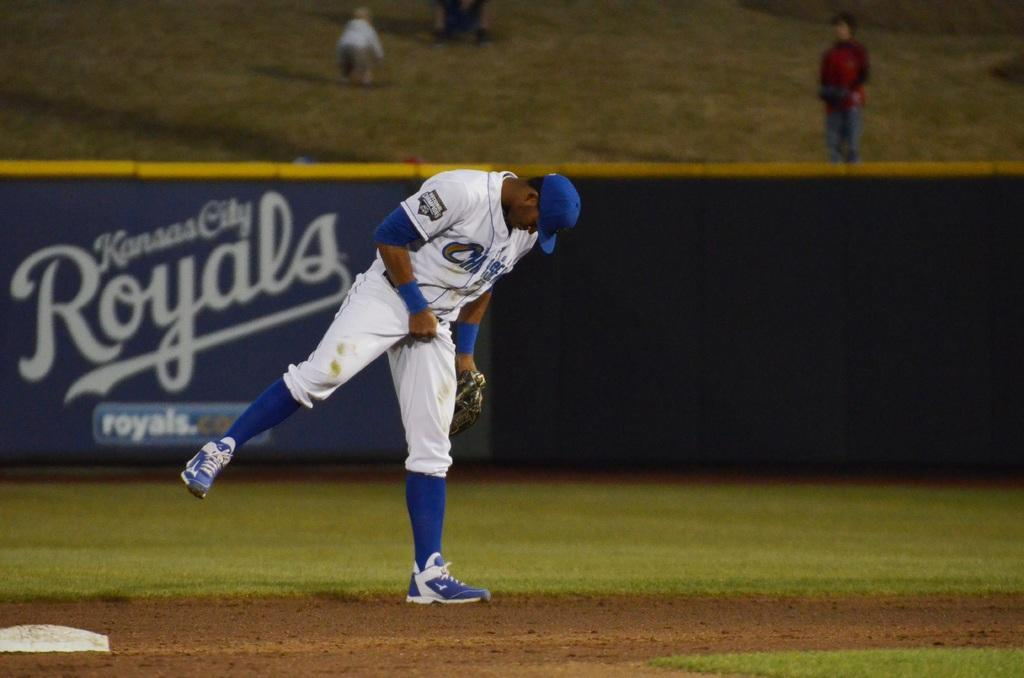<image>
Write a terse but informative summary of the picture. Man preparing to pitch a ball in front of a sign that says Kansais City Royals. 